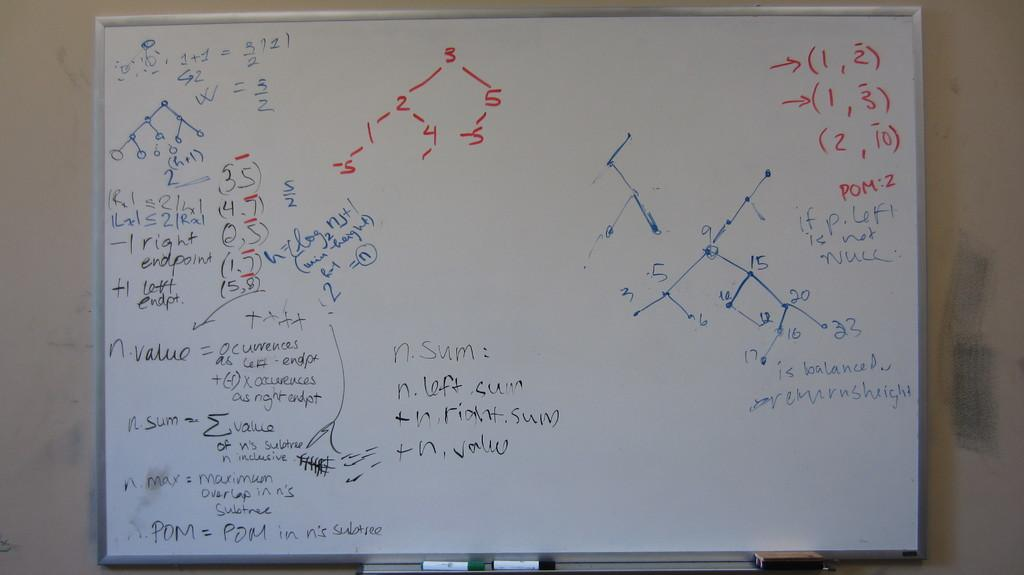<image>
Share a concise interpretation of the image provided. A whiteboard with formulas written upon in in marker with the number one repeated on the board several times. 